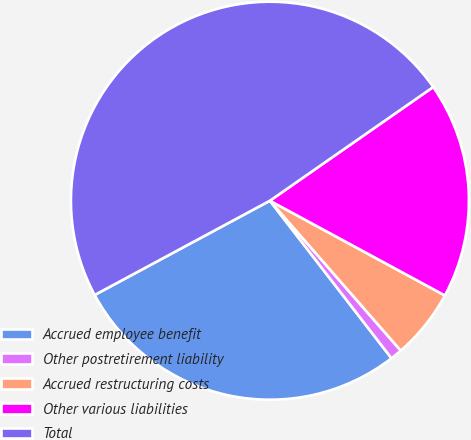Convert chart. <chart><loc_0><loc_0><loc_500><loc_500><pie_chart><fcel>Accrued employee benefit<fcel>Other postretirement liability<fcel>Accrued restructuring costs<fcel>Other various liabilities<fcel>Total<nl><fcel>27.61%<fcel>0.96%<fcel>5.68%<fcel>17.58%<fcel>48.18%<nl></chart> 